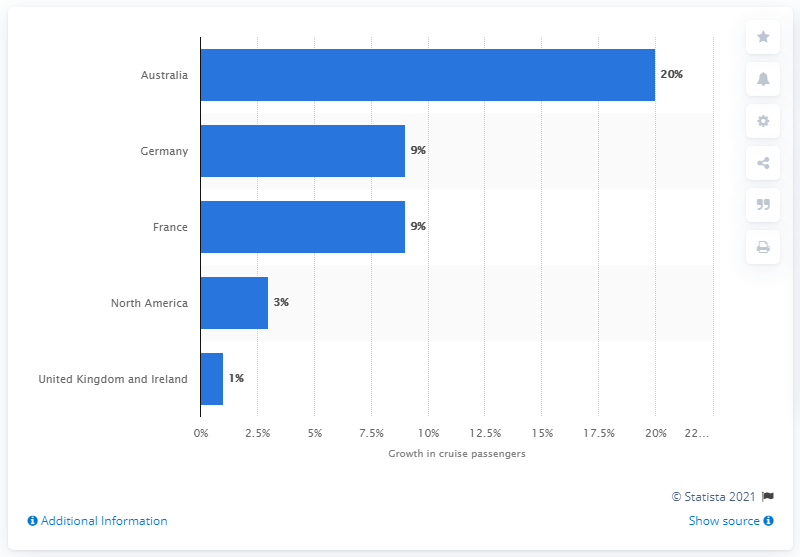What percentage of passenger numbers did Australia have in 2013? In 2013, Australia's passenger number growth was 20% in the cruise industry, as indicated by the bar graph. This represents a substantial increase, positioning Australia at the top compared to the growth in other regions shown. 